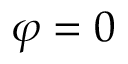Convert formula to latex. <formula><loc_0><loc_0><loc_500><loc_500>\varphi = 0</formula> 